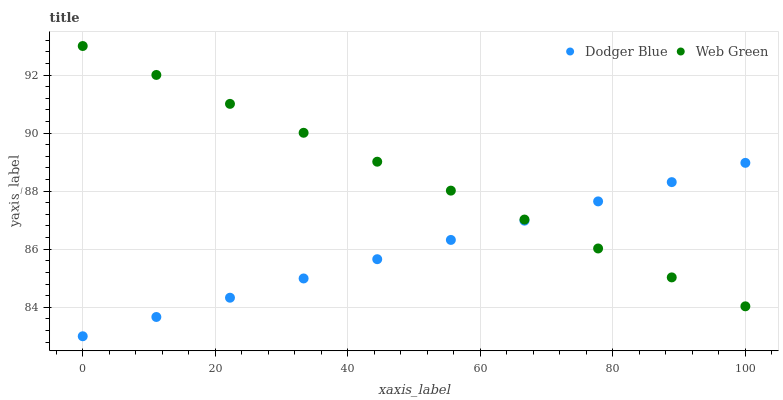Does Dodger Blue have the minimum area under the curve?
Answer yes or no. Yes. Does Web Green have the maximum area under the curve?
Answer yes or no. Yes. Does Web Green have the minimum area under the curve?
Answer yes or no. No. Is Web Green the smoothest?
Answer yes or no. Yes. Is Dodger Blue the roughest?
Answer yes or no. Yes. Is Web Green the roughest?
Answer yes or no. No. Does Dodger Blue have the lowest value?
Answer yes or no. Yes. Does Web Green have the lowest value?
Answer yes or no. No. Does Web Green have the highest value?
Answer yes or no. Yes. Does Web Green intersect Dodger Blue?
Answer yes or no. Yes. Is Web Green less than Dodger Blue?
Answer yes or no. No. Is Web Green greater than Dodger Blue?
Answer yes or no. No. 